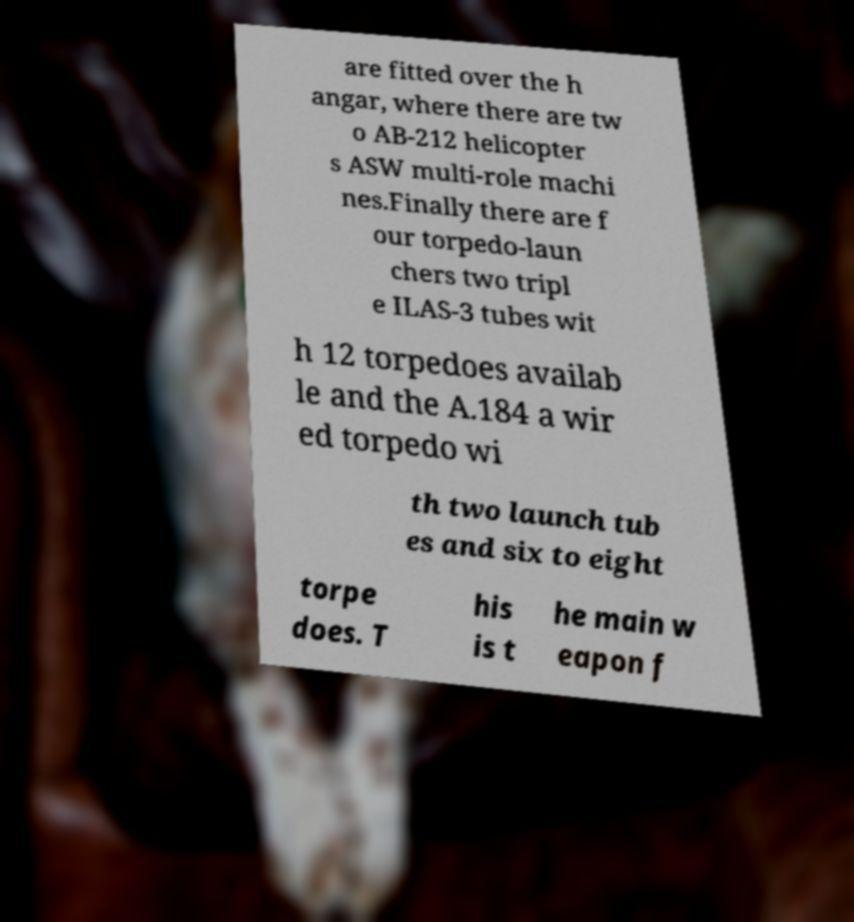Please read and relay the text visible in this image. What does it say? are fitted over the h angar, where there are tw o AB-212 helicopter s ASW multi-role machi nes.Finally there are f our torpedo-laun chers two tripl e ILAS-3 tubes wit h 12 torpedoes availab le and the A.184 a wir ed torpedo wi th two launch tub es and six to eight torpe does. T his is t he main w eapon f 